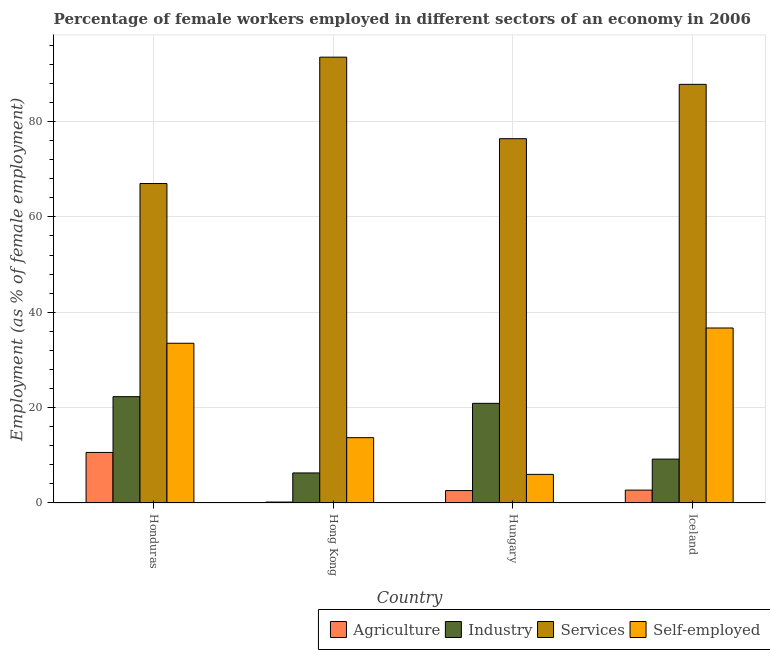How many different coloured bars are there?
Offer a terse response. 4. How many groups of bars are there?
Provide a succinct answer. 4. Are the number of bars per tick equal to the number of legend labels?
Make the answer very short. Yes. How many bars are there on the 4th tick from the left?
Offer a very short reply. 4. How many bars are there on the 2nd tick from the right?
Offer a terse response. 4. What is the label of the 2nd group of bars from the left?
Your response must be concise. Hong Kong. What is the percentage of female workers in agriculture in Iceland?
Provide a short and direct response. 2.7. Across all countries, what is the maximum percentage of self employed female workers?
Your answer should be compact. 36.7. In which country was the percentage of female workers in agriculture maximum?
Your answer should be very brief. Honduras. In which country was the percentage of female workers in agriculture minimum?
Your response must be concise. Hong Kong. What is the total percentage of female workers in industry in the graph?
Provide a succinct answer. 58.7. What is the difference between the percentage of female workers in agriculture in Honduras and that in Iceland?
Ensure brevity in your answer.  7.9. What is the difference between the percentage of female workers in services in Iceland and the percentage of female workers in industry in Hungary?
Your answer should be very brief. 66.9. What is the average percentage of female workers in services per country?
Make the answer very short. 81.18. What is the difference between the percentage of female workers in services and percentage of female workers in agriculture in Iceland?
Your answer should be very brief. 85.1. In how many countries, is the percentage of self employed female workers greater than 12 %?
Keep it short and to the point. 3. What is the ratio of the percentage of self employed female workers in Honduras to that in Hungary?
Offer a very short reply. 5.58. Is the difference between the percentage of self employed female workers in Hong Kong and Hungary greater than the difference between the percentage of female workers in industry in Hong Kong and Hungary?
Ensure brevity in your answer.  Yes. What is the difference between the highest and the second highest percentage of female workers in industry?
Offer a terse response. 1.4. What is the difference between the highest and the lowest percentage of female workers in industry?
Provide a short and direct response. 16. Is the sum of the percentage of female workers in industry in Hong Kong and Iceland greater than the maximum percentage of female workers in services across all countries?
Make the answer very short. No. What does the 3rd bar from the left in Hong Kong represents?
Provide a short and direct response. Services. What does the 4th bar from the right in Iceland represents?
Make the answer very short. Agriculture. Are all the bars in the graph horizontal?
Your response must be concise. No. How many countries are there in the graph?
Provide a short and direct response. 4. Does the graph contain grids?
Make the answer very short. Yes. Where does the legend appear in the graph?
Your response must be concise. Bottom right. How many legend labels are there?
Make the answer very short. 4. How are the legend labels stacked?
Your answer should be compact. Horizontal. What is the title of the graph?
Provide a succinct answer. Percentage of female workers employed in different sectors of an economy in 2006. Does "Secondary general education" appear as one of the legend labels in the graph?
Offer a very short reply. No. What is the label or title of the Y-axis?
Give a very brief answer. Employment (as % of female employment). What is the Employment (as % of female employment) of Agriculture in Honduras?
Give a very brief answer. 10.6. What is the Employment (as % of female employment) of Industry in Honduras?
Your response must be concise. 22.3. What is the Employment (as % of female employment) of Services in Honduras?
Offer a very short reply. 67. What is the Employment (as % of female employment) in Self-employed in Honduras?
Your answer should be very brief. 33.5. What is the Employment (as % of female employment) of Agriculture in Hong Kong?
Offer a terse response. 0.2. What is the Employment (as % of female employment) of Industry in Hong Kong?
Offer a very short reply. 6.3. What is the Employment (as % of female employment) of Services in Hong Kong?
Your response must be concise. 93.5. What is the Employment (as % of female employment) of Self-employed in Hong Kong?
Make the answer very short. 13.7. What is the Employment (as % of female employment) of Agriculture in Hungary?
Offer a very short reply. 2.6. What is the Employment (as % of female employment) of Industry in Hungary?
Make the answer very short. 20.9. What is the Employment (as % of female employment) in Services in Hungary?
Offer a terse response. 76.4. What is the Employment (as % of female employment) of Agriculture in Iceland?
Provide a succinct answer. 2.7. What is the Employment (as % of female employment) of Industry in Iceland?
Give a very brief answer. 9.2. What is the Employment (as % of female employment) in Services in Iceland?
Your answer should be very brief. 87.8. What is the Employment (as % of female employment) of Self-employed in Iceland?
Ensure brevity in your answer.  36.7. Across all countries, what is the maximum Employment (as % of female employment) of Agriculture?
Keep it short and to the point. 10.6. Across all countries, what is the maximum Employment (as % of female employment) in Industry?
Make the answer very short. 22.3. Across all countries, what is the maximum Employment (as % of female employment) in Services?
Offer a very short reply. 93.5. Across all countries, what is the maximum Employment (as % of female employment) of Self-employed?
Provide a succinct answer. 36.7. Across all countries, what is the minimum Employment (as % of female employment) of Agriculture?
Keep it short and to the point. 0.2. Across all countries, what is the minimum Employment (as % of female employment) in Industry?
Your answer should be very brief. 6.3. What is the total Employment (as % of female employment) of Agriculture in the graph?
Give a very brief answer. 16.1. What is the total Employment (as % of female employment) in Industry in the graph?
Provide a short and direct response. 58.7. What is the total Employment (as % of female employment) in Services in the graph?
Provide a succinct answer. 324.7. What is the total Employment (as % of female employment) in Self-employed in the graph?
Keep it short and to the point. 89.9. What is the difference between the Employment (as % of female employment) of Services in Honduras and that in Hong Kong?
Your answer should be compact. -26.5. What is the difference between the Employment (as % of female employment) of Self-employed in Honduras and that in Hong Kong?
Give a very brief answer. 19.8. What is the difference between the Employment (as % of female employment) in Agriculture in Honduras and that in Hungary?
Keep it short and to the point. 8. What is the difference between the Employment (as % of female employment) in Services in Honduras and that in Hungary?
Make the answer very short. -9.4. What is the difference between the Employment (as % of female employment) in Agriculture in Honduras and that in Iceland?
Offer a terse response. 7.9. What is the difference between the Employment (as % of female employment) in Industry in Honduras and that in Iceland?
Offer a terse response. 13.1. What is the difference between the Employment (as % of female employment) of Services in Honduras and that in Iceland?
Provide a succinct answer. -20.8. What is the difference between the Employment (as % of female employment) of Industry in Hong Kong and that in Hungary?
Offer a terse response. -14.6. What is the difference between the Employment (as % of female employment) of Services in Hong Kong and that in Hungary?
Provide a short and direct response. 17.1. What is the difference between the Employment (as % of female employment) in Self-employed in Hong Kong and that in Hungary?
Provide a short and direct response. 7.7. What is the difference between the Employment (as % of female employment) of Agriculture in Hong Kong and that in Iceland?
Offer a terse response. -2.5. What is the difference between the Employment (as % of female employment) in Industry in Hong Kong and that in Iceland?
Provide a short and direct response. -2.9. What is the difference between the Employment (as % of female employment) of Services in Hong Kong and that in Iceland?
Your answer should be compact. 5.7. What is the difference between the Employment (as % of female employment) of Agriculture in Hungary and that in Iceland?
Offer a terse response. -0.1. What is the difference between the Employment (as % of female employment) in Self-employed in Hungary and that in Iceland?
Provide a succinct answer. -30.7. What is the difference between the Employment (as % of female employment) in Agriculture in Honduras and the Employment (as % of female employment) in Services in Hong Kong?
Your answer should be compact. -82.9. What is the difference between the Employment (as % of female employment) of Industry in Honduras and the Employment (as % of female employment) of Services in Hong Kong?
Offer a very short reply. -71.2. What is the difference between the Employment (as % of female employment) of Industry in Honduras and the Employment (as % of female employment) of Self-employed in Hong Kong?
Offer a terse response. 8.6. What is the difference between the Employment (as % of female employment) of Services in Honduras and the Employment (as % of female employment) of Self-employed in Hong Kong?
Your answer should be compact. 53.3. What is the difference between the Employment (as % of female employment) of Agriculture in Honduras and the Employment (as % of female employment) of Industry in Hungary?
Your answer should be very brief. -10.3. What is the difference between the Employment (as % of female employment) of Agriculture in Honduras and the Employment (as % of female employment) of Services in Hungary?
Ensure brevity in your answer.  -65.8. What is the difference between the Employment (as % of female employment) in Industry in Honduras and the Employment (as % of female employment) in Services in Hungary?
Your response must be concise. -54.1. What is the difference between the Employment (as % of female employment) in Services in Honduras and the Employment (as % of female employment) in Self-employed in Hungary?
Give a very brief answer. 61. What is the difference between the Employment (as % of female employment) of Agriculture in Honduras and the Employment (as % of female employment) of Industry in Iceland?
Ensure brevity in your answer.  1.4. What is the difference between the Employment (as % of female employment) in Agriculture in Honduras and the Employment (as % of female employment) in Services in Iceland?
Make the answer very short. -77.2. What is the difference between the Employment (as % of female employment) in Agriculture in Honduras and the Employment (as % of female employment) in Self-employed in Iceland?
Your answer should be very brief. -26.1. What is the difference between the Employment (as % of female employment) in Industry in Honduras and the Employment (as % of female employment) in Services in Iceland?
Ensure brevity in your answer.  -65.5. What is the difference between the Employment (as % of female employment) of Industry in Honduras and the Employment (as % of female employment) of Self-employed in Iceland?
Provide a succinct answer. -14.4. What is the difference between the Employment (as % of female employment) of Services in Honduras and the Employment (as % of female employment) of Self-employed in Iceland?
Your answer should be very brief. 30.3. What is the difference between the Employment (as % of female employment) in Agriculture in Hong Kong and the Employment (as % of female employment) in Industry in Hungary?
Your response must be concise. -20.7. What is the difference between the Employment (as % of female employment) in Agriculture in Hong Kong and the Employment (as % of female employment) in Services in Hungary?
Ensure brevity in your answer.  -76.2. What is the difference between the Employment (as % of female employment) of Industry in Hong Kong and the Employment (as % of female employment) of Services in Hungary?
Your response must be concise. -70.1. What is the difference between the Employment (as % of female employment) of Industry in Hong Kong and the Employment (as % of female employment) of Self-employed in Hungary?
Provide a short and direct response. 0.3. What is the difference between the Employment (as % of female employment) in Services in Hong Kong and the Employment (as % of female employment) in Self-employed in Hungary?
Offer a very short reply. 87.5. What is the difference between the Employment (as % of female employment) of Agriculture in Hong Kong and the Employment (as % of female employment) of Industry in Iceland?
Make the answer very short. -9. What is the difference between the Employment (as % of female employment) in Agriculture in Hong Kong and the Employment (as % of female employment) in Services in Iceland?
Make the answer very short. -87.6. What is the difference between the Employment (as % of female employment) of Agriculture in Hong Kong and the Employment (as % of female employment) of Self-employed in Iceland?
Your answer should be compact. -36.5. What is the difference between the Employment (as % of female employment) in Industry in Hong Kong and the Employment (as % of female employment) in Services in Iceland?
Your answer should be very brief. -81.5. What is the difference between the Employment (as % of female employment) in Industry in Hong Kong and the Employment (as % of female employment) in Self-employed in Iceland?
Provide a short and direct response. -30.4. What is the difference between the Employment (as % of female employment) of Services in Hong Kong and the Employment (as % of female employment) of Self-employed in Iceland?
Your answer should be compact. 56.8. What is the difference between the Employment (as % of female employment) in Agriculture in Hungary and the Employment (as % of female employment) in Industry in Iceland?
Ensure brevity in your answer.  -6.6. What is the difference between the Employment (as % of female employment) of Agriculture in Hungary and the Employment (as % of female employment) of Services in Iceland?
Your answer should be compact. -85.2. What is the difference between the Employment (as % of female employment) in Agriculture in Hungary and the Employment (as % of female employment) in Self-employed in Iceland?
Your answer should be very brief. -34.1. What is the difference between the Employment (as % of female employment) in Industry in Hungary and the Employment (as % of female employment) in Services in Iceland?
Your response must be concise. -66.9. What is the difference between the Employment (as % of female employment) in Industry in Hungary and the Employment (as % of female employment) in Self-employed in Iceland?
Keep it short and to the point. -15.8. What is the difference between the Employment (as % of female employment) of Services in Hungary and the Employment (as % of female employment) of Self-employed in Iceland?
Offer a terse response. 39.7. What is the average Employment (as % of female employment) of Agriculture per country?
Offer a terse response. 4.03. What is the average Employment (as % of female employment) in Industry per country?
Keep it short and to the point. 14.68. What is the average Employment (as % of female employment) of Services per country?
Offer a terse response. 81.17. What is the average Employment (as % of female employment) of Self-employed per country?
Offer a terse response. 22.48. What is the difference between the Employment (as % of female employment) in Agriculture and Employment (as % of female employment) in Industry in Honduras?
Offer a very short reply. -11.7. What is the difference between the Employment (as % of female employment) of Agriculture and Employment (as % of female employment) of Services in Honduras?
Your answer should be very brief. -56.4. What is the difference between the Employment (as % of female employment) in Agriculture and Employment (as % of female employment) in Self-employed in Honduras?
Offer a very short reply. -22.9. What is the difference between the Employment (as % of female employment) of Industry and Employment (as % of female employment) of Services in Honduras?
Your answer should be compact. -44.7. What is the difference between the Employment (as % of female employment) in Services and Employment (as % of female employment) in Self-employed in Honduras?
Make the answer very short. 33.5. What is the difference between the Employment (as % of female employment) of Agriculture and Employment (as % of female employment) of Industry in Hong Kong?
Give a very brief answer. -6.1. What is the difference between the Employment (as % of female employment) in Agriculture and Employment (as % of female employment) in Services in Hong Kong?
Your answer should be compact. -93.3. What is the difference between the Employment (as % of female employment) in Industry and Employment (as % of female employment) in Services in Hong Kong?
Your answer should be compact. -87.2. What is the difference between the Employment (as % of female employment) in Industry and Employment (as % of female employment) in Self-employed in Hong Kong?
Your response must be concise. -7.4. What is the difference between the Employment (as % of female employment) of Services and Employment (as % of female employment) of Self-employed in Hong Kong?
Your answer should be very brief. 79.8. What is the difference between the Employment (as % of female employment) in Agriculture and Employment (as % of female employment) in Industry in Hungary?
Offer a very short reply. -18.3. What is the difference between the Employment (as % of female employment) of Agriculture and Employment (as % of female employment) of Services in Hungary?
Make the answer very short. -73.8. What is the difference between the Employment (as % of female employment) in Agriculture and Employment (as % of female employment) in Self-employed in Hungary?
Offer a terse response. -3.4. What is the difference between the Employment (as % of female employment) of Industry and Employment (as % of female employment) of Services in Hungary?
Your answer should be compact. -55.5. What is the difference between the Employment (as % of female employment) of Services and Employment (as % of female employment) of Self-employed in Hungary?
Keep it short and to the point. 70.4. What is the difference between the Employment (as % of female employment) of Agriculture and Employment (as % of female employment) of Services in Iceland?
Keep it short and to the point. -85.1. What is the difference between the Employment (as % of female employment) of Agriculture and Employment (as % of female employment) of Self-employed in Iceland?
Provide a succinct answer. -34. What is the difference between the Employment (as % of female employment) in Industry and Employment (as % of female employment) in Services in Iceland?
Your response must be concise. -78.6. What is the difference between the Employment (as % of female employment) of Industry and Employment (as % of female employment) of Self-employed in Iceland?
Keep it short and to the point. -27.5. What is the difference between the Employment (as % of female employment) in Services and Employment (as % of female employment) in Self-employed in Iceland?
Ensure brevity in your answer.  51.1. What is the ratio of the Employment (as % of female employment) in Industry in Honduras to that in Hong Kong?
Your response must be concise. 3.54. What is the ratio of the Employment (as % of female employment) in Services in Honduras to that in Hong Kong?
Provide a succinct answer. 0.72. What is the ratio of the Employment (as % of female employment) in Self-employed in Honduras to that in Hong Kong?
Provide a succinct answer. 2.45. What is the ratio of the Employment (as % of female employment) of Agriculture in Honduras to that in Hungary?
Your response must be concise. 4.08. What is the ratio of the Employment (as % of female employment) of Industry in Honduras to that in Hungary?
Offer a very short reply. 1.07. What is the ratio of the Employment (as % of female employment) in Services in Honduras to that in Hungary?
Provide a succinct answer. 0.88. What is the ratio of the Employment (as % of female employment) of Self-employed in Honduras to that in Hungary?
Your answer should be compact. 5.58. What is the ratio of the Employment (as % of female employment) in Agriculture in Honduras to that in Iceland?
Your answer should be very brief. 3.93. What is the ratio of the Employment (as % of female employment) in Industry in Honduras to that in Iceland?
Ensure brevity in your answer.  2.42. What is the ratio of the Employment (as % of female employment) of Services in Honduras to that in Iceland?
Your answer should be compact. 0.76. What is the ratio of the Employment (as % of female employment) in Self-employed in Honduras to that in Iceland?
Your response must be concise. 0.91. What is the ratio of the Employment (as % of female employment) in Agriculture in Hong Kong to that in Hungary?
Offer a terse response. 0.08. What is the ratio of the Employment (as % of female employment) of Industry in Hong Kong to that in Hungary?
Make the answer very short. 0.3. What is the ratio of the Employment (as % of female employment) in Services in Hong Kong to that in Hungary?
Make the answer very short. 1.22. What is the ratio of the Employment (as % of female employment) in Self-employed in Hong Kong to that in Hungary?
Provide a short and direct response. 2.28. What is the ratio of the Employment (as % of female employment) in Agriculture in Hong Kong to that in Iceland?
Provide a short and direct response. 0.07. What is the ratio of the Employment (as % of female employment) of Industry in Hong Kong to that in Iceland?
Make the answer very short. 0.68. What is the ratio of the Employment (as % of female employment) of Services in Hong Kong to that in Iceland?
Give a very brief answer. 1.06. What is the ratio of the Employment (as % of female employment) of Self-employed in Hong Kong to that in Iceland?
Offer a terse response. 0.37. What is the ratio of the Employment (as % of female employment) in Industry in Hungary to that in Iceland?
Your answer should be compact. 2.27. What is the ratio of the Employment (as % of female employment) of Services in Hungary to that in Iceland?
Provide a short and direct response. 0.87. What is the ratio of the Employment (as % of female employment) of Self-employed in Hungary to that in Iceland?
Your answer should be very brief. 0.16. What is the difference between the highest and the second highest Employment (as % of female employment) of Agriculture?
Make the answer very short. 7.9. What is the difference between the highest and the second highest Employment (as % of female employment) of Industry?
Your response must be concise. 1.4. What is the difference between the highest and the second highest Employment (as % of female employment) of Services?
Keep it short and to the point. 5.7. What is the difference between the highest and the lowest Employment (as % of female employment) of Agriculture?
Provide a short and direct response. 10.4. What is the difference between the highest and the lowest Employment (as % of female employment) in Self-employed?
Your response must be concise. 30.7. 